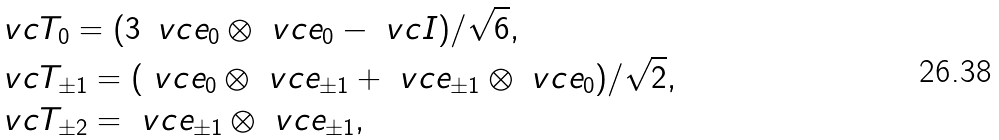Convert formula to latex. <formula><loc_0><loc_0><loc_500><loc_500>& \ v c { T } _ { 0 } = ( 3 \, \ v c { e } _ { 0 } \otimes \ v c { e } _ { 0 } - \ v c { I } ) / \sqrt { 6 } , \\ & \ v c { T } _ { \pm 1 } = ( \ v c { e } _ { 0 } \otimes \ v c { e } _ { \pm 1 } + \ v c { e } _ { \pm 1 } \otimes \ v c { e } _ { 0 } ) / \sqrt { 2 } , \\ & \ v c { T } _ { \pm 2 } = \ v c { e } _ { \pm 1 } \otimes \ v c { e } _ { \pm 1 } ,</formula> 